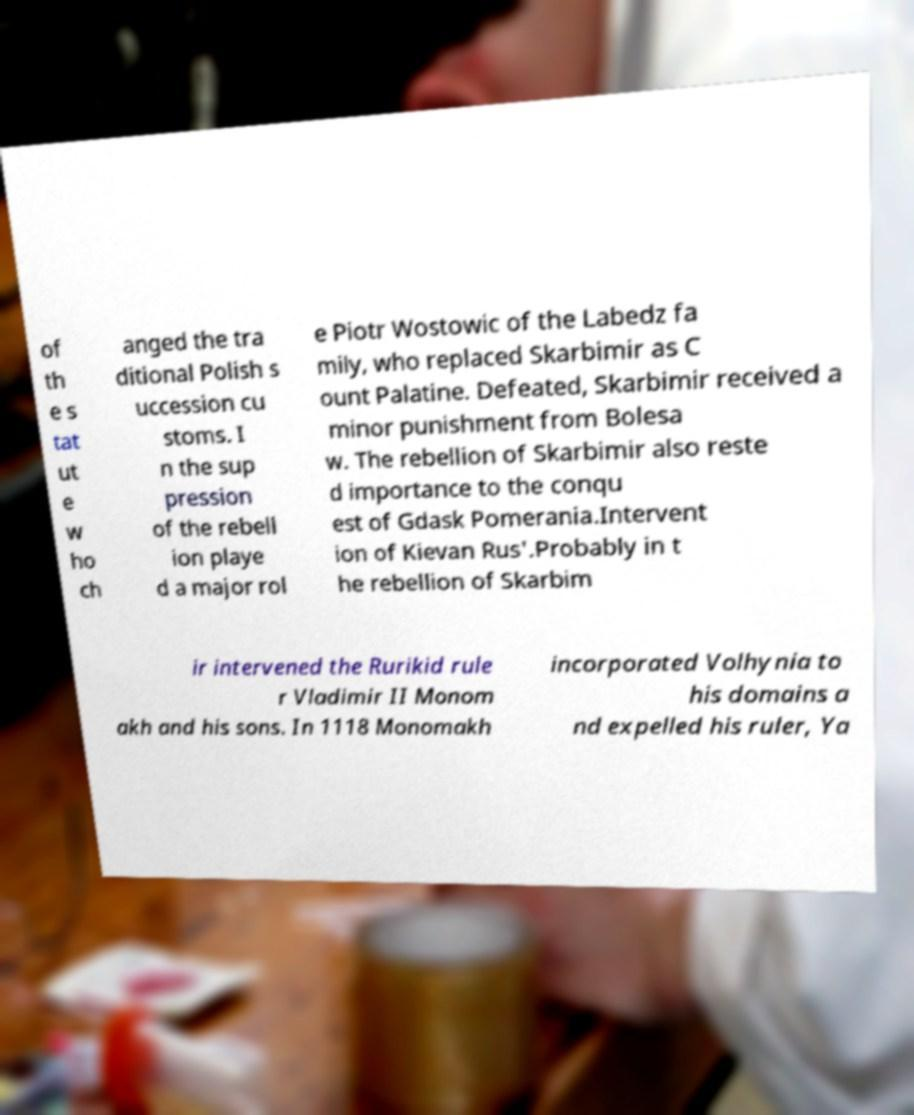Could you extract and type out the text from this image? of th e s tat ut e w ho ch anged the tra ditional Polish s uccession cu stoms. I n the sup pression of the rebell ion playe d a major rol e Piotr Wostowic of the Labedz fa mily, who replaced Skarbimir as C ount Palatine. Defeated, Skarbimir received a minor punishment from Bolesa w. The rebellion of Skarbimir also reste d importance to the conqu est of Gdask Pomerania.Intervent ion of Kievan Rus'.Probably in t he rebellion of Skarbim ir intervened the Rurikid rule r Vladimir II Monom akh and his sons. In 1118 Monomakh incorporated Volhynia to his domains a nd expelled his ruler, Ya 